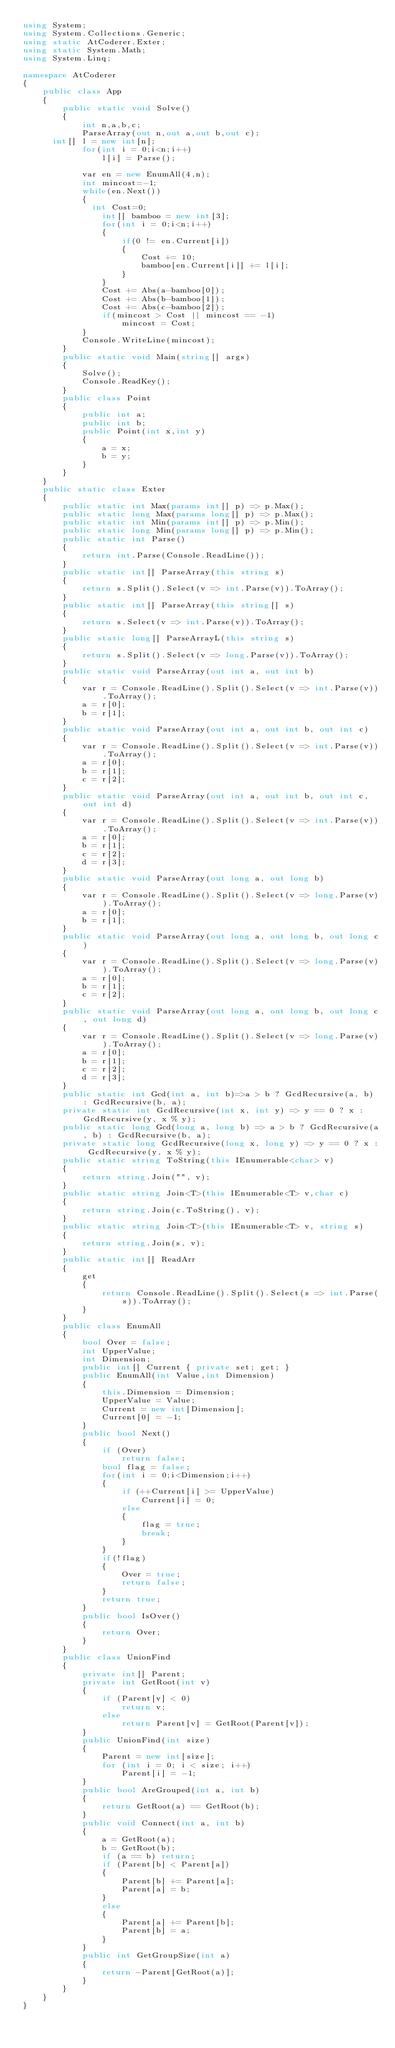Convert code to text. <code><loc_0><loc_0><loc_500><loc_500><_C#_>using System;
using System.Collections.Generic;
using static AtCoderer.Exter;
using static System.Math;
using System.Linq;

namespace AtCoderer
{
    public class App
    {
        public static void Solve()
        {
          	int n,a,b,c;
          	ParseArray(out n,out a,out b,out c);
			int[] l = new int[n];
          	for(int i = 0;i<n;i++)
              	l[i] = Parse();
          	
          	var en = new EnumAll(4,n);
          	int mincost=-1;
          	while(en.Next())
            {
          		int Cost=0;
              	int[] bamboo = new int[3];
              	for(int i = 0;i<n;i++)
                {
                  	if(0 != en.Current[i])
                    {
                      	Cost += 10;
                      	bamboo[en.Current[i]] += l[i];
                    }
                }
                Cost += Abs(a-bamboo[0]);
                Cost += Abs(b-bamboo[1]);
                Cost += Abs(c-bamboo[2]);
              	if(mincost > Cost || mincost == -1)
                  	mincost = Cost;
            }
          	Console.WriteLine(mincost);
        }
        public static void Main(string[] args)
        {
            Solve();
            Console.ReadKey();
        }
        public class Point
        {
            public int a;
            public int b;
            public Point(int x,int y)
            {
                a = x;
                b = y;
            }
        }
    }
    public static class Exter
    {   
        public static int Max(params int[] p) => p.Max();
        public static long Max(params long[] p) => p.Max();
        public static int Min(params int[] p) => p.Min();
        public static long Min(params long[] p) => p.Min();
        public static int Parse()
        {
            return int.Parse(Console.ReadLine());
        }
        public static int[] ParseArray(this string s)
        {
            return s.Split().Select(v => int.Parse(v)).ToArray();
        }
        public static int[] ParseArray(this string[] s)
        {
            return s.Select(v => int.Parse(v)).ToArray();
        }
        public static long[] ParseArrayL(this string s)
        {
            return s.Split().Select(v => long.Parse(v)).ToArray();
        }
        public static void ParseArray(out int a, out int b)
        {
            var r = Console.ReadLine().Split().Select(v => int.Parse(v)).ToArray();
            a = r[0];
            b = r[1];
        }
        public static void ParseArray(out int a, out int b, out int c)
        {
            var r = Console.ReadLine().Split().Select(v => int.Parse(v)).ToArray();
            a = r[0];
            b = r[1];
            c = r[2];
        }
        public static void ParseArray(out int a, out int b, out int c, out int d)
        {
            var r = Console.ReadLine().Split().Select(v => int.Parse(v)).ToArray();
            a = r[0];
            b = r[1];
            c = r[2];
            d = r[3];
        }
        public static void ParseArray(out long a, out long b)
        {
            var r = Console.ReadLine().Split().Select(v => long.Parse(v)).ToArray();
            a = r[0];
            b = r[1];
        }
        public static void ParseArray(out long a, out long b, out long c)
        {
            var r = Console.ReadLine().Split().Select(v => long.Parse(v)).ToArray();
            a = r[0];
            b = r[1];
            c = r[2];
        }
        public static void ParseArray(out long a, out long b, out long c, out long d)
        {
            var r = Console.ReadLine().Split().Select(v => long.Parse(v)).ToArray();
            a = r[0];
            b = r[1];
            c = r[2];
            d = r[3];
        }
        public static int Gcd(int a, int b)=>a > b ? GcdRecursive(a, b) : GcdRecursive(b, a);
        private static int GcdRecursive(int x, int y) => y == 0 ? x : GcdRecursive(y, x % y);
        public static long Gcd(long a, long b) => a > b ? GcdRecursive(a, b) : GcdRecursive(b, a);
        private static long GcdRecursive(long x, long y) => y == 0 ? x : GcdRecursive(y, x % y);
        public static string ToString(this IEnumerable<char> v)
        {
            return string.Join("", v);
        }
        public static string Join<T>(this IEnumerable<T> v,char c)
        {
            return string.Join(c.ToString(), v);
        }
        public static string Join<T>(this IEnumerable<T> v, string s)
        {
            return string.Join(s, v);
        }
        public static int[] ReadArr
        {
            get
            {
                return Console.ReadLine().Split().Select(s => int.Parse(s)).ToArray();
            }
        }
        public class EnumAll
        {
            bool Over = false;
            int UpperValue;
            int Dimension;
            public int[] Current { private set; get; }
            public EnumAll(int Value,int Dimension)
            {
                this.Dimension = Dimension;
                UpperValue = Value;
                Current = new int[Dimension];
                Current[0] = -1;
            }
            public bool Next()
            {
                if (Over)
                    return false;
                bool flag = false;
                for(int i = 0;i<Dimension;i++)
                {
                    if (++Current[i] >= UpperValue)
                        Current[i] = 0;
                    else
                    {
                        flag = true;
                        break;
                    }
                }
                if(!flag)
                {
                    Over = true;
                    return false;
                }
                return true;
            }
            public bool IsOver()
            {
                return Over;
            }
        }
        public class UnionFind
        {
            private int[] Parent;
            private int GetRoot(int v)
            {
                if (Parent[v] < 0)
                    return v;
                else
                    return Parent[v] = GetRoot(Parent[v]);
            }
            public UnionFind(int size)
            {
                Parent = new int[size];
                for (int i = 0; i < size; i++)
                    Parent[i] = -1;
            }
            public bool AreGrouped(int a, int b)
            {
                return GetRoot(a) == GetRoot(b);
            }
            public void Connect(int a, int b)
            {
                a = GetRoot(a);
                b = GetRoot(b);
                if (a == b) return;
                if (Parent[b] < Parent[a])
                {
                    Parent[b] += Parent[a];
                    Parent[a] = b;
                }
                else
                {
                    Parent[a] += Parent[b];
                    Parent[b] = a;
                }
            }
            public int GetGroupSize(int a)
            {
                return -Parent[GetRoot(a)];
            }
        }
    }
}
</code> 